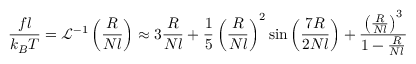Convert formula to latex. <formula><loc_0><loc_0><loc_500><loc_500>{ \frac { f l } { k _ { B } T } } = { \mathcal { L } } ^ { - 1 } \left ( { \frac { R } { N l } } \right ) \approx 3 { \frac { R } { N l } } + { \frac { 1 } { 5 } } \left ( { \frac { R } { N l } } \right ) ^ { 2 } \sin \left ( { \frac { 7 R } { 2 N l } } \right ) + { \frac { \left ( { \frac { R } { N l } } \right ) ^ { 3 } } { 1 - { \frac { R } { N l } } } }</formula> 